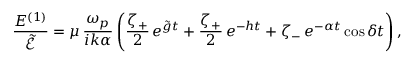<formula> <loc_0><loc_0><loc_500><loc_500>\frac { E ^ { ( 1 ) } } { \widetilde { \mathcal { E } } } = \mu \, \frac { \omega _ { p } } { i k \alpha } \left ( \frac { \zeta _ { + } } 2 \, e ^ { \tilde { g } t } + \frac { \zeta _ { + } } 2 \, e ^ { - h t } + \zeta _ { - } \, e ^ { - \alpha t } \cos { \delta t } \right ) ,</formula> 